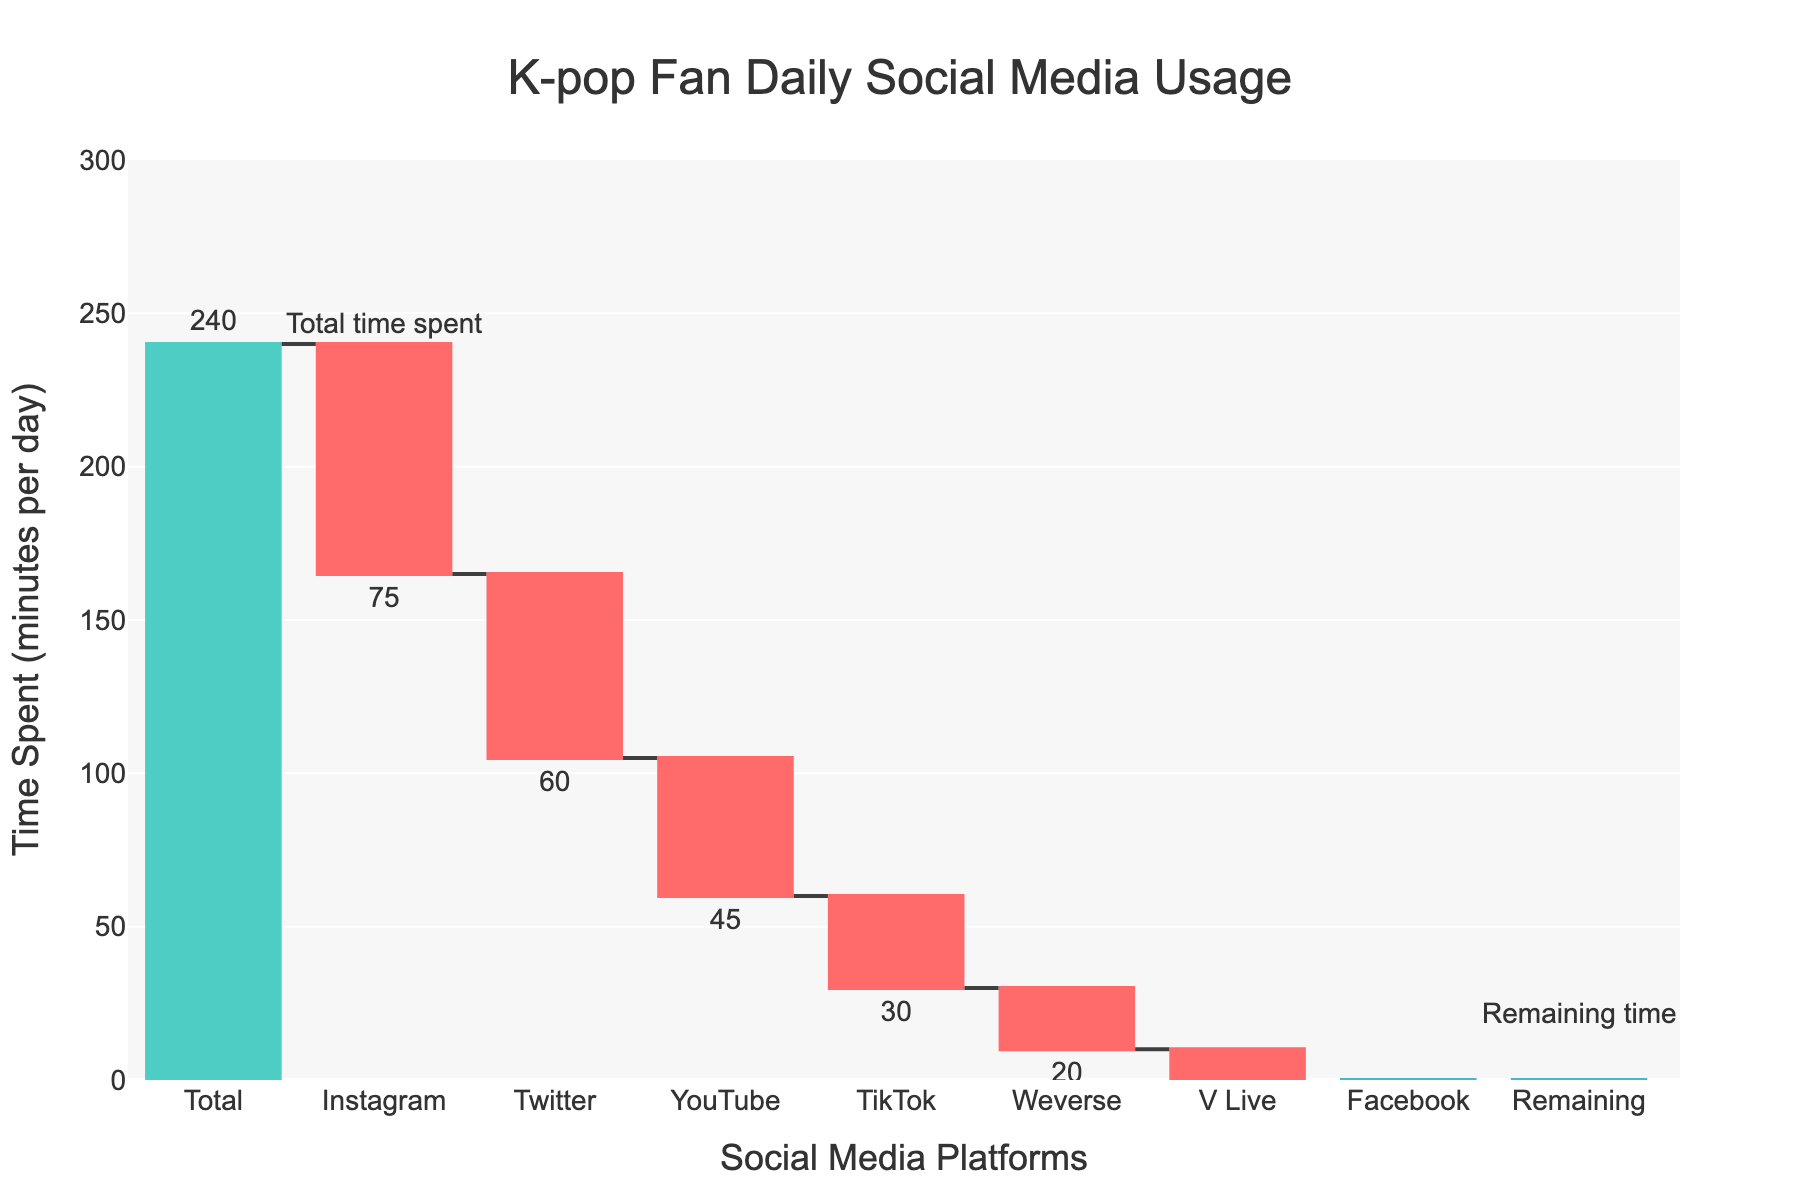What is the title of the figure? The title can be found right at the top of the chart, clearly indicating what the figure is about. It reads: "K-pop Fan Daily Social Media Usage"
Answer: K-pop Fan Daily Social Media Usage Which platform has the highest daily usage? By looking at the waterfall chart bars that start from the total time, the platform with the largest decrease (longest bar) at the beginning is Instagram.
Answer: Instagram How much total time do K-pop fans spend on Weverse and V Live combined? To find the combined time, sum the minutes spent on Weverse and V Live: -20 (Weverse) + -15 (V Live) = -35 minutes.
Answer: -35 minutes How does the time spent on TikTok compare to Twitter? To compare these platforms, subtract the minutes spent on TikTok from those spent on Twitter: -60 (Twitter) - (-30) (TikTok) = -30 minutes. Thus, more time is spent on Twitter compared to TikTok.
Answer: More time on Twitter by 30 minutes What is the remaining time after spending on all listed platforms? The chart specifies this with the "Remaining" label at the end of the waterfall, showing a positive value of 15 minutes remaining.
Answer: 15 minutes Why is there an increase in the 'Remaining' category? The 'Remaining' category has a positive bar indicating leftover time. This suggests that after accounting for all the time spent on specified platforms, there are still some unaccounted minutes in the total time.
Answer: Unspent or remaining time Which platform sees the least time spent by K-pop fans? The platform with the smallest negative value (shortest bar in the waterfall) on the spending side is Facebook, with -10 minutes.
Answer: Facebook What is the total decrease in time when moving from YouTube usage to Facebook usage? To determine this, sum the time spent on YouTube, TikTok, V Live, and Facebook: -45 (YouTube) - 30 (TikTok) - 15 (V Live) - 10 (Facebook) = -100 minutes.
Answer: -100 minutes What is the color used to indicate decreasing values in the chart? By observing the chart, we see that the bars for decreasing values are in red.
Answer: Red 